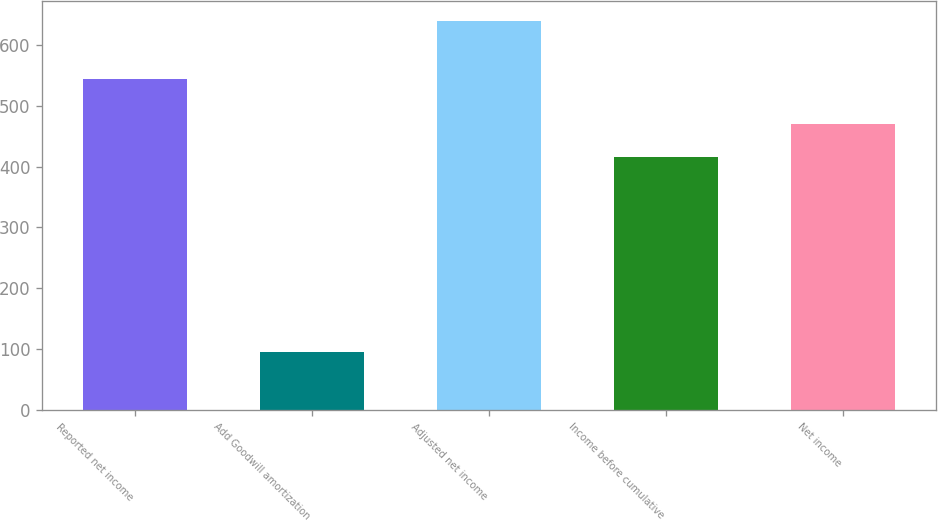Convert chart to OTSL. <chart><loc_0><loc_0><loc_500><loc_500><bar_chart><fcel>Reported net income<fcel>Add Goodwill amortization<fcel>Adjusted net income<fcel>Income before cumulative<fcel>Net income<nl><fcel>544<fcel>95<fcel>639<fcel>415<fcel>469.4<nl></chart> 